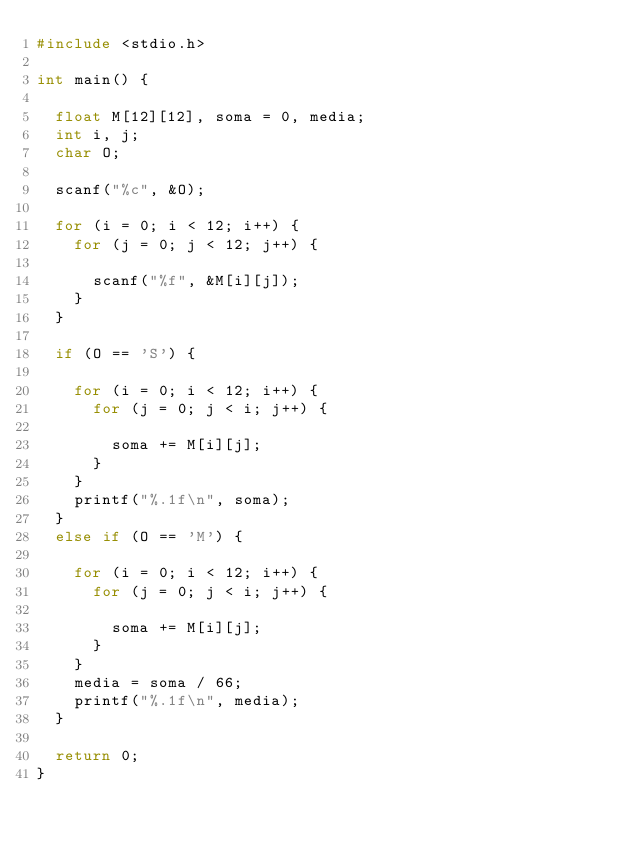<code> <loc_0><loc_0><loc_500><loc_500><_C_>#include <stdio.h>

int main() {

	float M[12][12], soma = 0, media;
	int i, j;
	char O;

	scanf("%c", &O);

	for (i = 0; i < 12; i++) {
		for (j = 0; j < 12; j++) {

			scanf("%f", &M[i][j]);
		}
	}

	if (O == 'S') {

		for (i = 0; i < 12; i++) {
			for (j = 0; j < i; j++) {

				soma += M[i][j];
			}
		}
		printf("%.1f\n", soma);
	}
	else if (O == 'M') {

		for (i = 0; i < 12; i++) {
			for (j = 0; j < i; j++) {

				soma += M[i][j];
			}
		}
		media = soma / 66;
		printf("%.1f\n", media);
	}

	return 0;
}</code> 